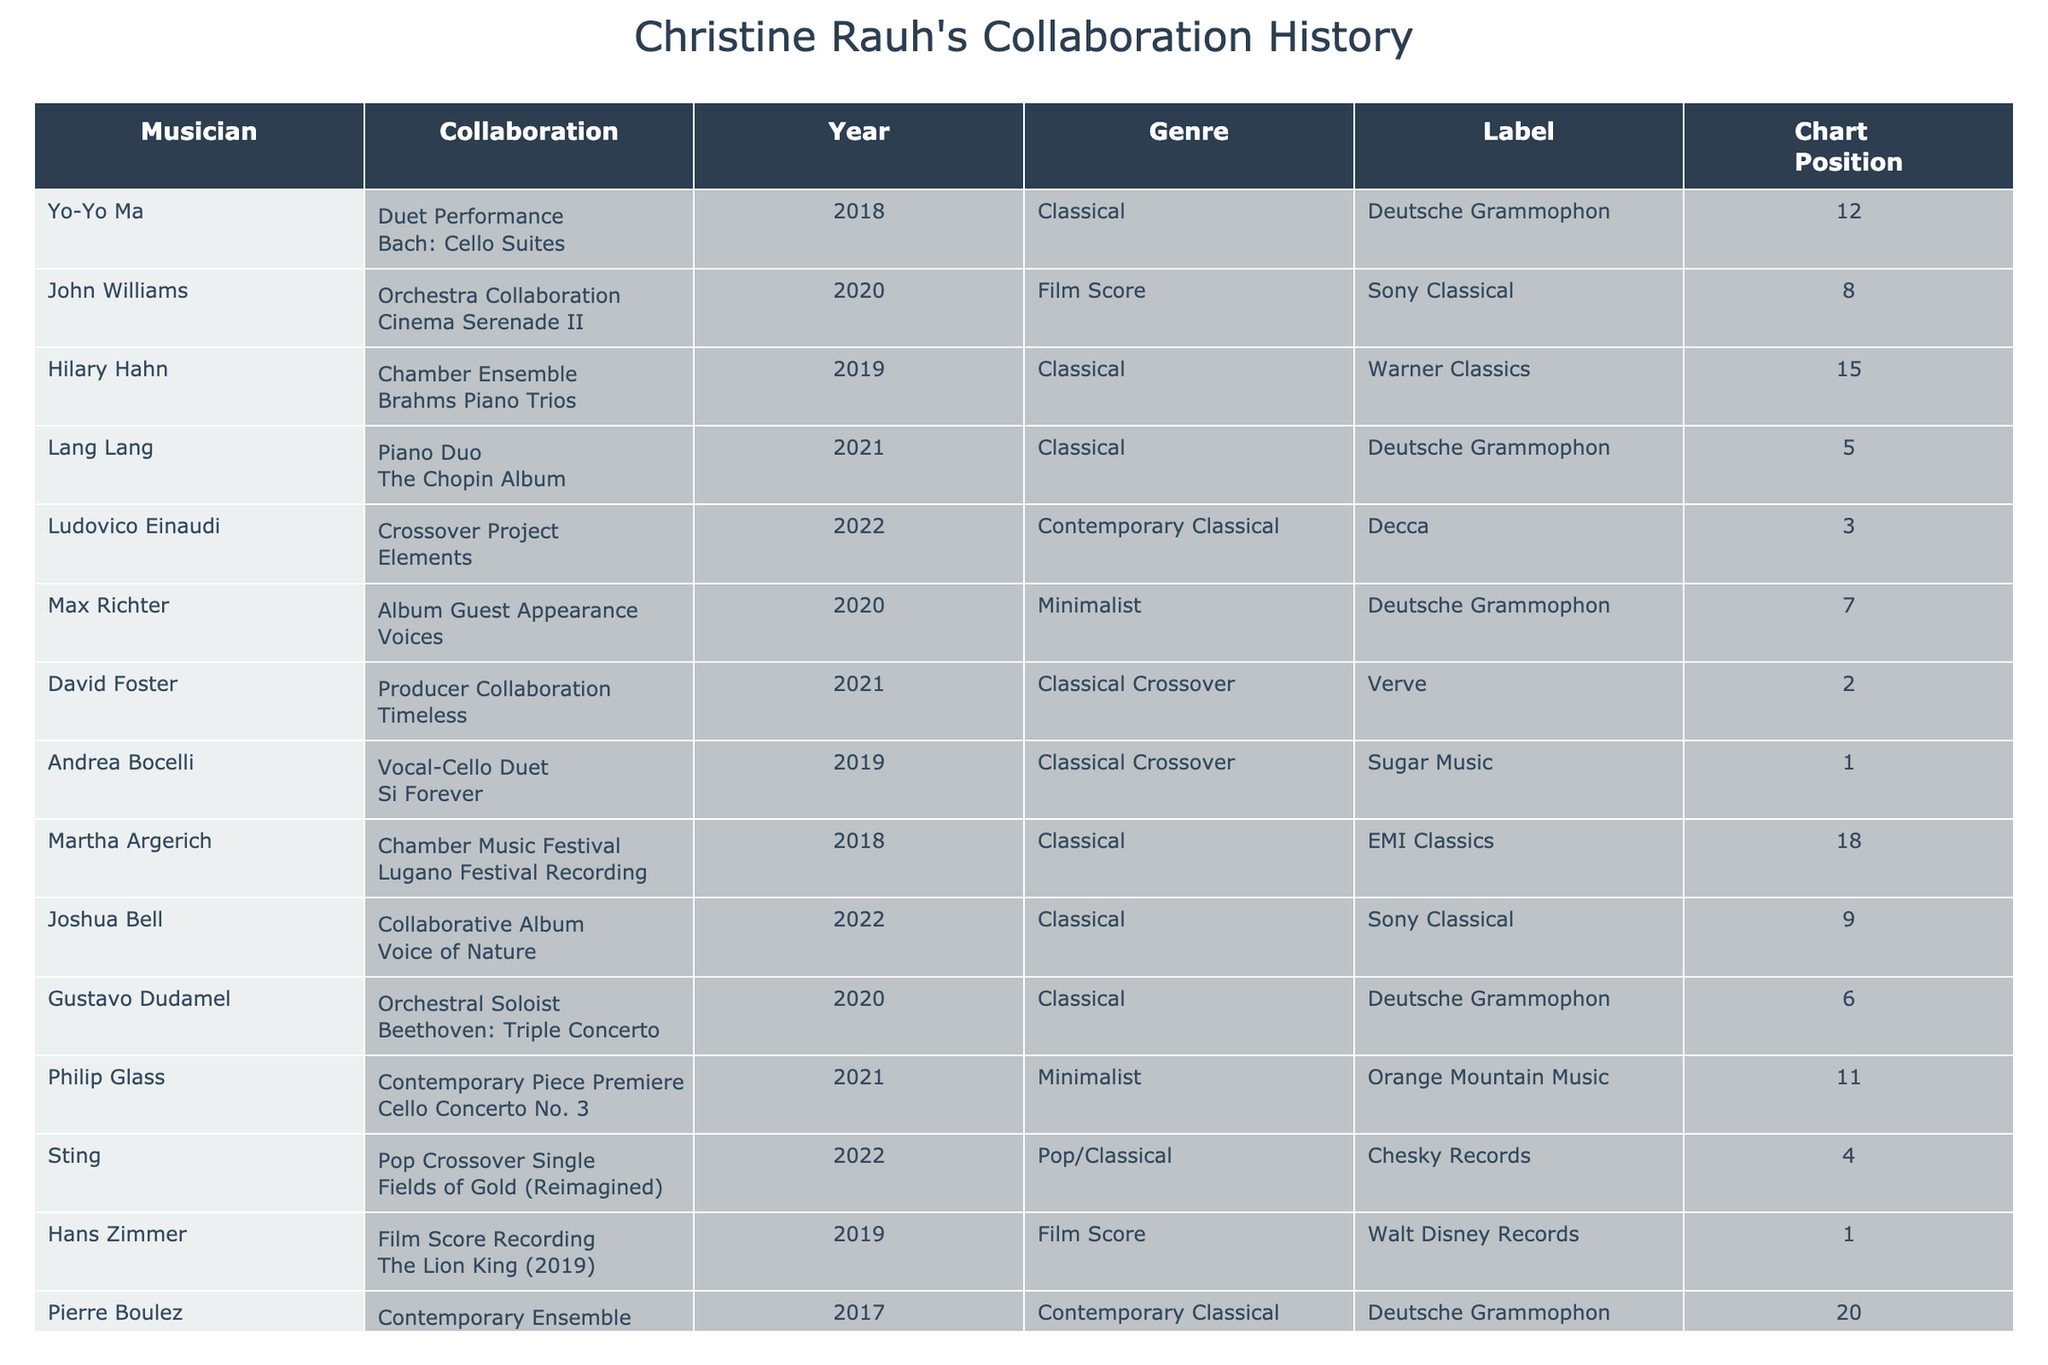What is the highest chart position achieved by Christine Rauh? The highest chart position in the table is '1', which is achieved by Andrea Bocelli in 2019 and Hans Zimmer in 2019.
Answer: 1 Who collaborated with Christine Rauh in 2020? In 2020, Christine Rauh collaborated with John Williams and Max Richter.
Answer: John Williams and Max Richter What type of collaboration did Christine Rauh have with Yo-Yo Ma? The collaboration with Yo-Yo Ma was a duet performance.
Answer: Duet Performance How many projects did Christine Rauh collaborate on in 2021? In 2021, Christine Rauh collaborated on three projects: with Lang Lang, David Foster, and Philip Glass.
Answer: 3 Which genre had the most collaborations listed in the table? The genre 'Classical' has the most collaborations listed, with seven entries.
Answer: Classical What is the average chart position of all collaborations in 2022? The chart positions for 2022 are 5 (Lang Lang), 3 (Ludovico Einaudi), 4 (Sting), and 9 (Joshua Bell), with an average of (5 + 3 + 4 + 9) / 4 = 21 / 4 = 5.25.
Answer: 5.25 Did Christine Rauh have a collaboration that reached chart position 2? Yes, the collaboration with David Foster in 2021 reached chart position 2.
Answer: Yes Which collaboration had the earliest year listed in the table? The earliest year listed is 2017 for the project 'Sur Incises' with Pierre Boulez.
Answer: 2017 What is the total number of distinct musicians Christine Rauh collaborated with? There are ten distinct musicians listed in the table.
Answer: 10 Which collaboration type had the least amount of entries in the table? The 'Chamber Music Festival' collaboration is the only one listed, indicating it has the least entries.
Answer: Chamber Music Festival 